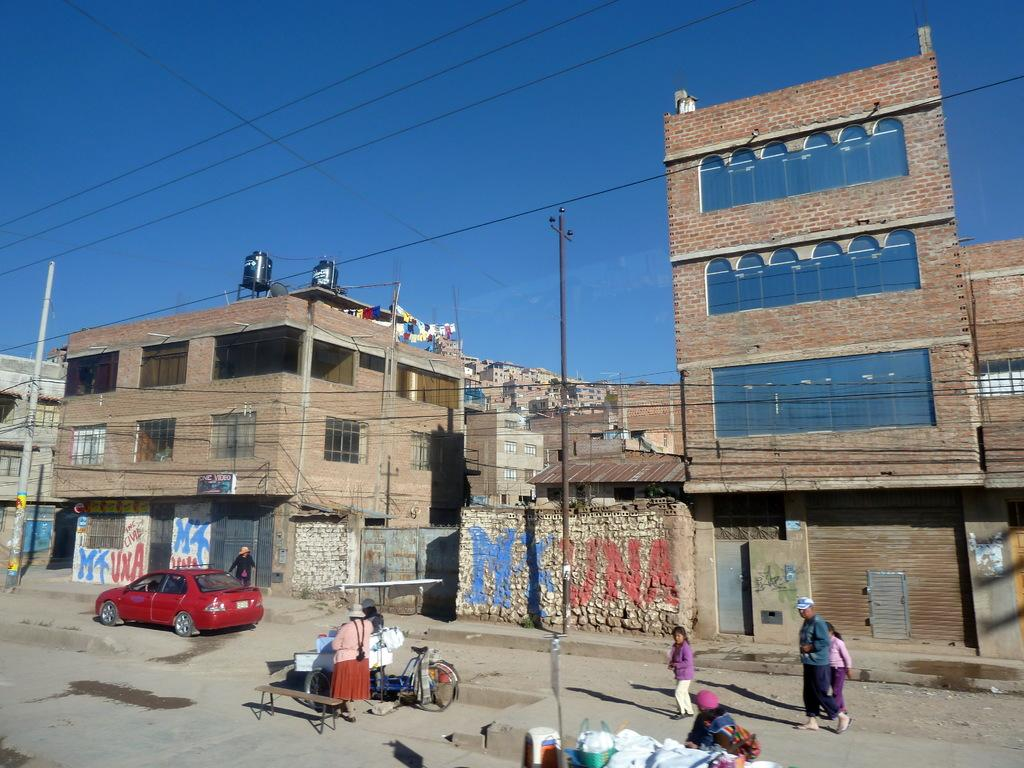What is the main subject in the center of the image? There are buildings in the center of the image. What type of transportation can be seen at the bottom of the image? Bicycles and cars are present at the bottom of the image. Are there any people visible in the image? Yes, people are in the image, specifically at the bottom. What items can be seen at the bottom of the image besides transportation and people? Bags and poles are visible at the bottom of the image. What is visible at the top of the image? Wires and the sky are visible at the top of the image. How does the payment system work for the level of digestion in the image? There is no payment system or digestion mentioned in the image; it primarily features buildings, bicycles, cars, people, bags, poles, wires, and the sky. 